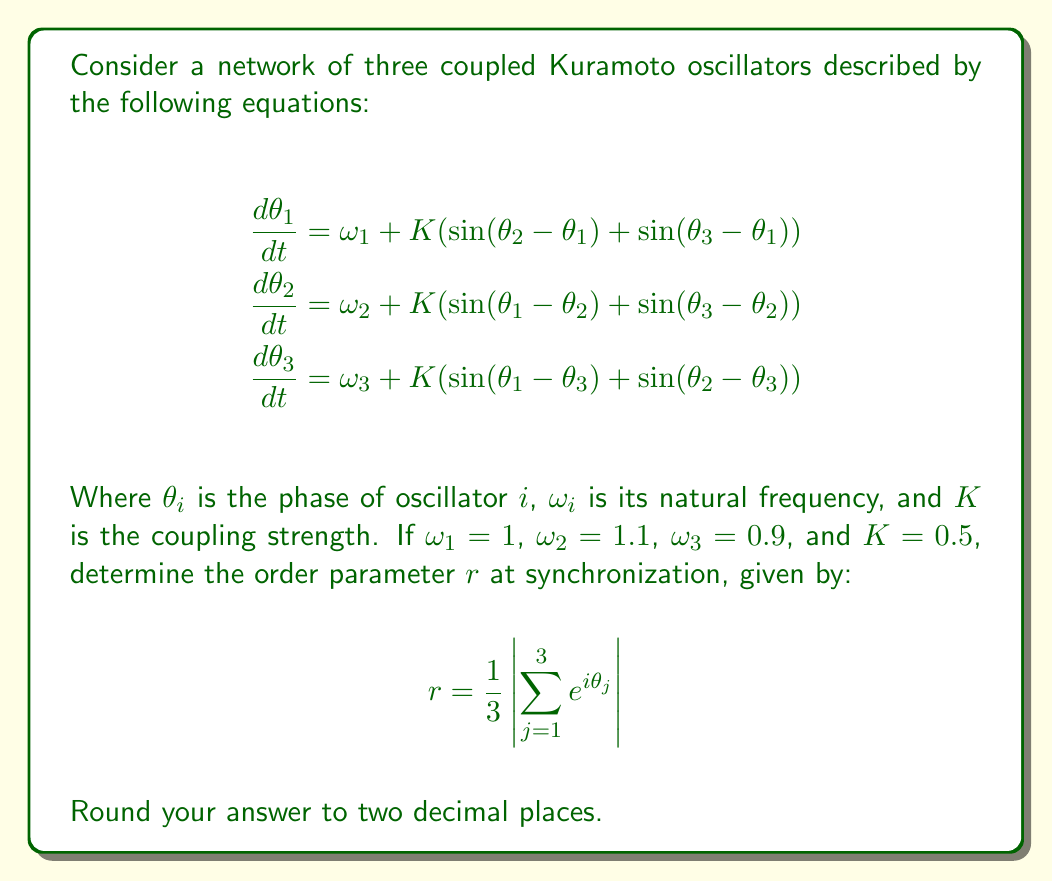Provide a solution to this math problem. To solve this problem, we'll follow these steps:

1) In the synchronized state, the phase differences between oscillators become constant. Let's define $\phi_{ij} = \theta_i - \theta_j$.

2) At synchronization, we have:
   $$\frac{d\phi_{ij}}{dt} = \frac{d\theta_i}{dt} - \frac{d\theta_j}{dt} = 0$$

3) Using the given equations, we can write:
   $$\omega_1 - \omega_2 + K(\sin(\phi_{21}) + \sin(\phi_{31}) - \sin(\phi_{12}) - \sin(\phi_{32})) = 0$$
   $$\omega_2 - \omega_3 + K(\sin(\phi_{12}) + \sin(\phi_{32}) - \sin(\phi_{23}) - \sin(\phi_{13})) = 0$$

4) Note that $\phi_{ij} = -\phi_{ji}$ and $\phi_{12} + \phi_{23} + \phi_{31} = 0$. Let's set $\phi_{12} = \alpha$ and $\phi_{23} = \beta$. Then $\phi_{31} = -(\alpha + \beta)$.

5) Substituting these into our equations:
   $$-0.1 + K(-\sin(\alpha) - \sin(\alpha + \beta) + \sin(\alpha) - \sin(\beta)) = 0$$
   $$0.2 + K(\sin(\alpha) - \sin(\beta) + \sin(\beta) + \sin(\alpha + \beta)) = 0$$

6) With $K = 0.5$, we can solve these numerically to get:
   $\alpha \approx 0.3351$ and $\beta \approx 0.2234$

7) Now we can calculate the order parameter:
   $$r = \frac{1}{3}\left|1 + e^{i\alpha} + e^{-i(\alpha + \beta)}\right|$$

8) Substituting the values and calculating:
   $$r \approx 0.9895$$

9) Rounding to two decimal places gives 0.99.
Answer: 0.99 